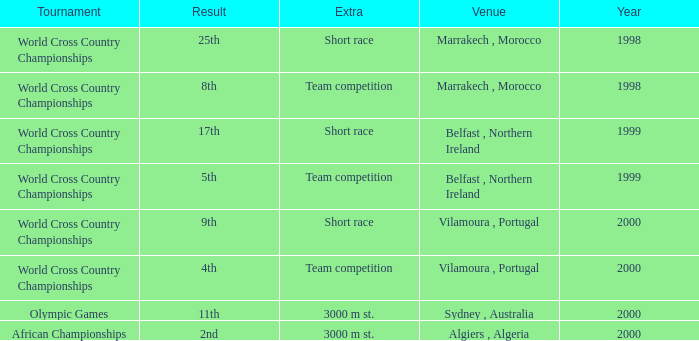Would you mind parsing the complete table? {'header': ['Tournament', 'Result', 'Extra', 'Venue', 'Year'], 'rows': [['World Cross Country Championships', '25th', 'Short race', 'Marrakech , Morocco', '1998'], ['World Cross Country Championships', '8th', 'Team competition', 'Marrakech , Morocco', '1998'], ['World Cross Country Championships', '17th', 'Short race', 'Belfast , Northern Ireland', '1999'], ['World Cross Country Championships', '5th', 'Team competition', 'Belfast , Northern Ireland', '1999'], ['World Cross Country Championships', '9th', 'Short race', 'Vilamoura , Portugal', '2000'], ['World Cross Country Championships', '4th', 'Team competition', 'Vilamoura , Portugal', '2000'], ['Olympic Games', '11th', '3000 m st.', 'Sydney , Australia', '2000'], ['African Championships', '2nd', '3000 m st.', 'Algiers , Algeria', '2000']]} Tell me the venue for extra of short race and year less than 1999 Marrakech , Morocco. 